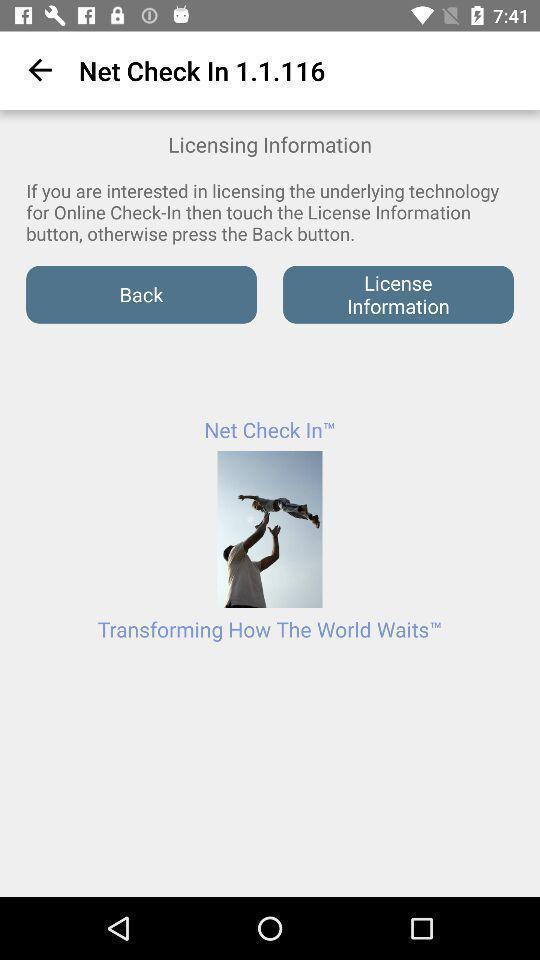What is the overall content of this screenshot? Page showing the licensing information. 